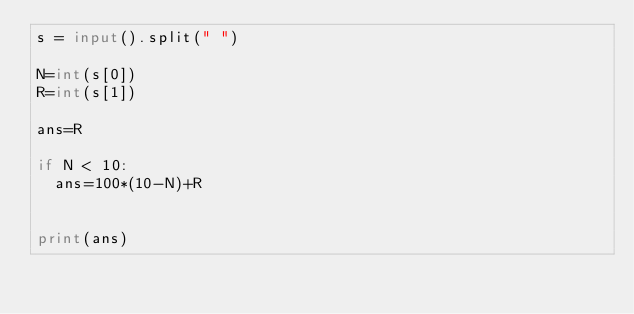<code> <loc_0><loc_0><loc_500><loc_500><_Python_>s = input().split(" ")

N=int(s[0])
R=int(s[1])

ans=R

if N < 10:
  ans=100*(10-N)+R
 
  
print(ans)



</code> 